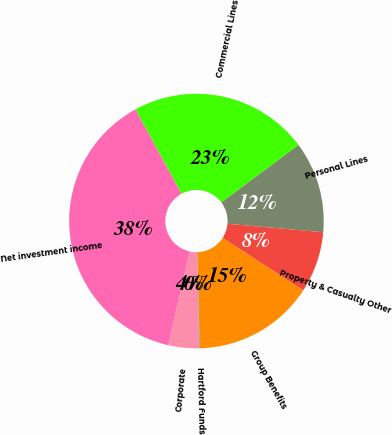Convert chart. <chart><loc_0><loc_0><loc_500><loc_500><pie_chart><fcel>Commercial Lines<fcel>Personal Lines<fcel>Property & Casualty Other<fcel>Group Benefits<fcel>Hartford Funds<fcel>Corporate<fcel>Net investment income<nl><fcel>22.77%<fcel>11.59%<fcel>7.75%<fcel>15.43%<fcel>0.07%<fcel>3.91%<fcel>38.47%<nl></chart> 